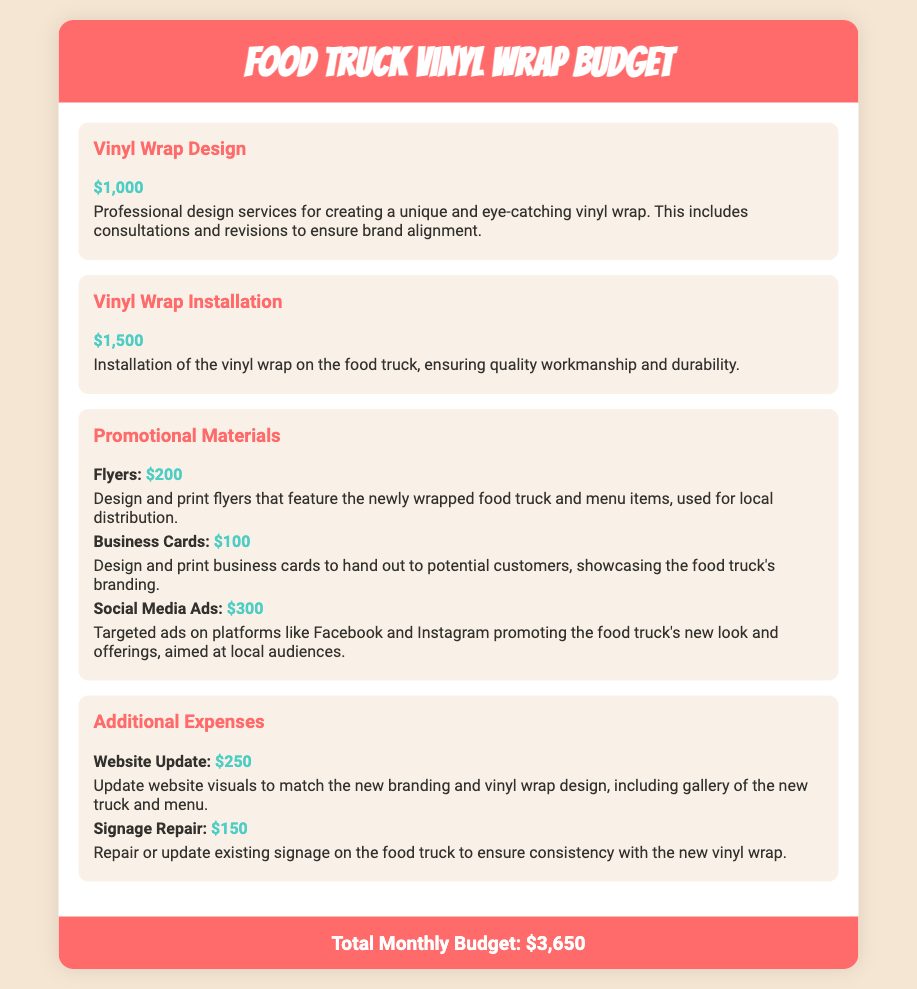What is the budget for vinyl wrap design? The budget for vinyl wrap design is specifically mentioned under a separate expense item, which is $1,000.
Answer: $1,000 How much does vinyl wrap installation cost? The document states that the cost for vinyl wrap installation is $1,500.
Answer: $1,500 What is the total monthly budget? The total monthly budget aggregates all listed expenses, arriving at a total of $3,650.
Answer: $3,650 How much is allocated for social media ads? The document specifies that $300 is allocated for social media ads, promoting the food truck's new look.
Answer: $300 What are the costs associated with business cards? The document details that the cost for business cards is $100 for design and print.
Answer: $100 What additional expense involves website updates? The document outlines that $250 is set aside for website update visuals matching the new branding.
Answer: $250 How much is budgeted for flyers? The document indicates that the budget for flyers is $200 for design and print.
Answer: $200 Which item has the lowest cost? The document lists the cost of business cards at $100, making it the lowest expense.
Answer: $100 What is the total cost of promotional materials? The promotional materials total can be calculated as $200 (flyers) + $100 (business cards) + $300 (social media ads) = $600.
Answer: $600 